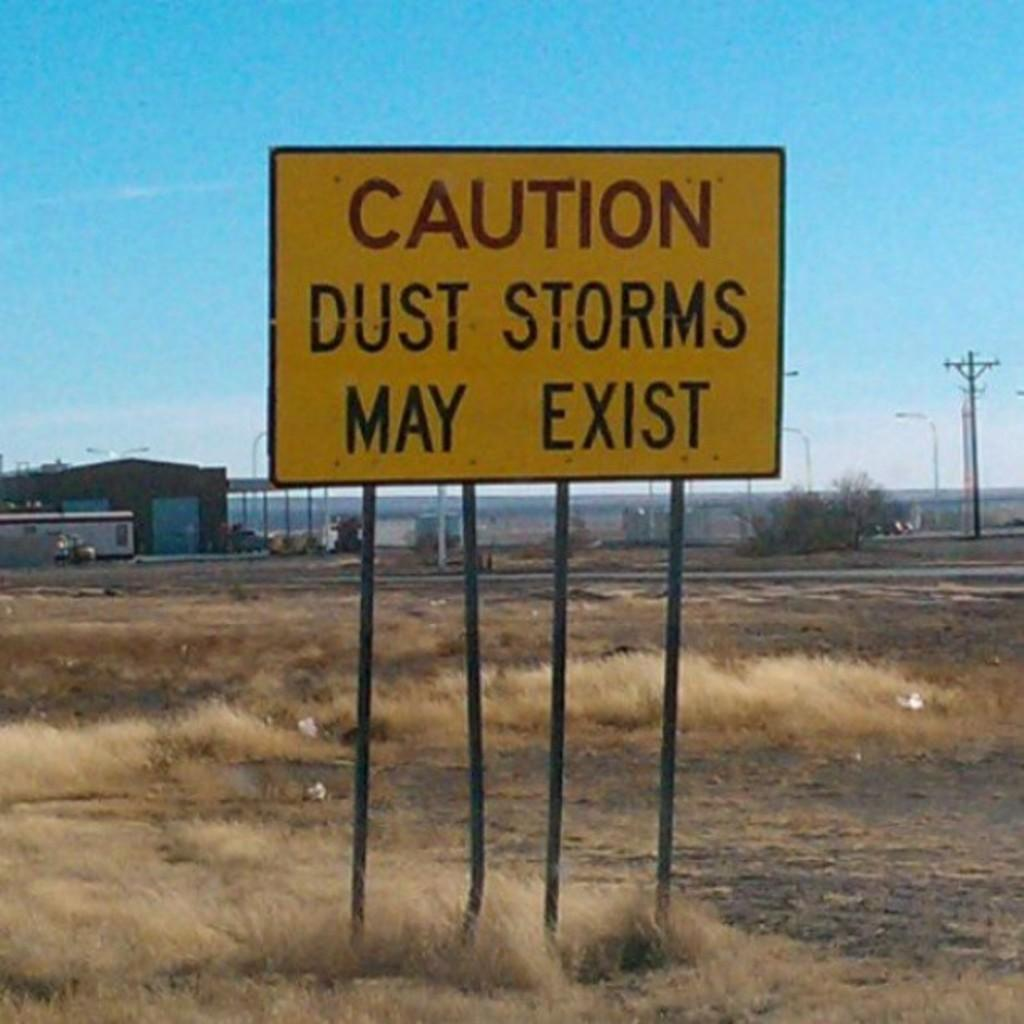<image>
Summarize the visual content of the image. A yellow sign in a dirt field with little dried grass warns that dust storms may exist. 